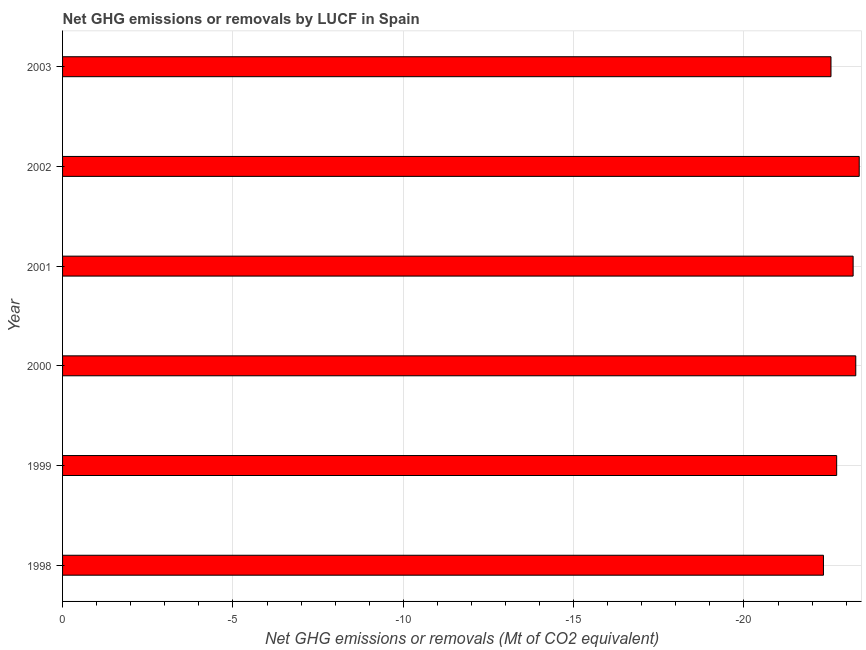Does the graph contain any zero values?
Provide a short and direct response. Yes. Does the graph contain grids?
Make the answer very short. Yes. What is the title of the graph?
Your response must be concise. Net GHG emissions or removals by LUCF in Spain. What is the label or title of the X-axis?
Offer a terse response. Net GHG emissions or removals (Mt of CO2 equivalent). What is the sum of the ghg net emissions or removals?
Provide a short and direct response. 0. What is the average ghg net emissions or removals per year?
Offer a terse response. 0. What is the median ghg net emissions or removals?
Make the answer very short. 0. In how many years, is the ghg net emissions or removals greater than -1 Mt?
Offer a very short reply. 0. In how many years, is the ghg net emissions or removals greater than the average ghg net emissions or removals taken over all years?
Ensure brevity in your answer.  0. How many bars are there?
Your answer should be compact. 0. How many years are there in the graph?
Your answer should be very brief. 6. Are the values on the major ticks of X-axis written in scientific E-notation?
Your response must be concise. No. What is the Net GHG emissions or removals (Mt of CO2 equivalent) of 1999?
Ensure brevity in your answer.  0. What is the Net GHG emissions or removals (Mt of CO2 equivalent) in 2000?
Provide a short and direct response. 0. What is the Net GHG emissions or removals (Mt of CO2 equivalent) in 2003?
Your answer should be very brief. 0. 